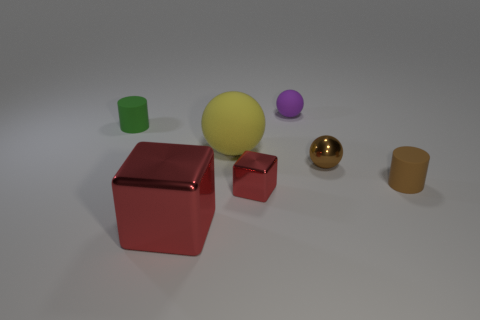What is the color of the shiny thing that is the same shape as the large rubber thing?
Offer a very short reply. Brown. The tiny cube has what color?
Offer a very short reply. Red. How many other objects are there of the same material as the tiny purple sphere?
Provide a short and direct response. 3. What number of red objects are matte objects or large matte spheres?
Your answer should be very brief. 0. There is a red thing that is to the right of the large red cube; is its shape the same as the red thing on the left side of the yellow matte ball?
Provide a short and direct response. Yes. There is a large ball; is it the same color as the small cylinder behind the brown ball?
Your answer should be compact. No. There is a small matte cylinder that is left of the small red cube; is its color the same as the large sphere?
Make the answer very short. No. What number of things are big cyan cubes or small red metal things in front of the tiny rubber sphere?
Provide a succinct answer. 1. What material is the object that is on the right side of the small purple thing and left of the tiny brown matte thing?
Offer a very short reply. Metal. There is a small cylinder in front of the small green rubber object; what is it made of?
Provide a short and direct response. Rubber. 